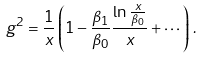Convert formula to latex. <formula><loc_0><loc_0><loc_500><loc_500>g ^ { 2 } = \frac { 1 } { x } \left ( 1 - \frac { \beta _ { 1 } } { \beta _ { 0 } } \frac { \ln \frac { x } { \beta _ { 0 } } } { x } + \cdots \right ) \, .</formula> 